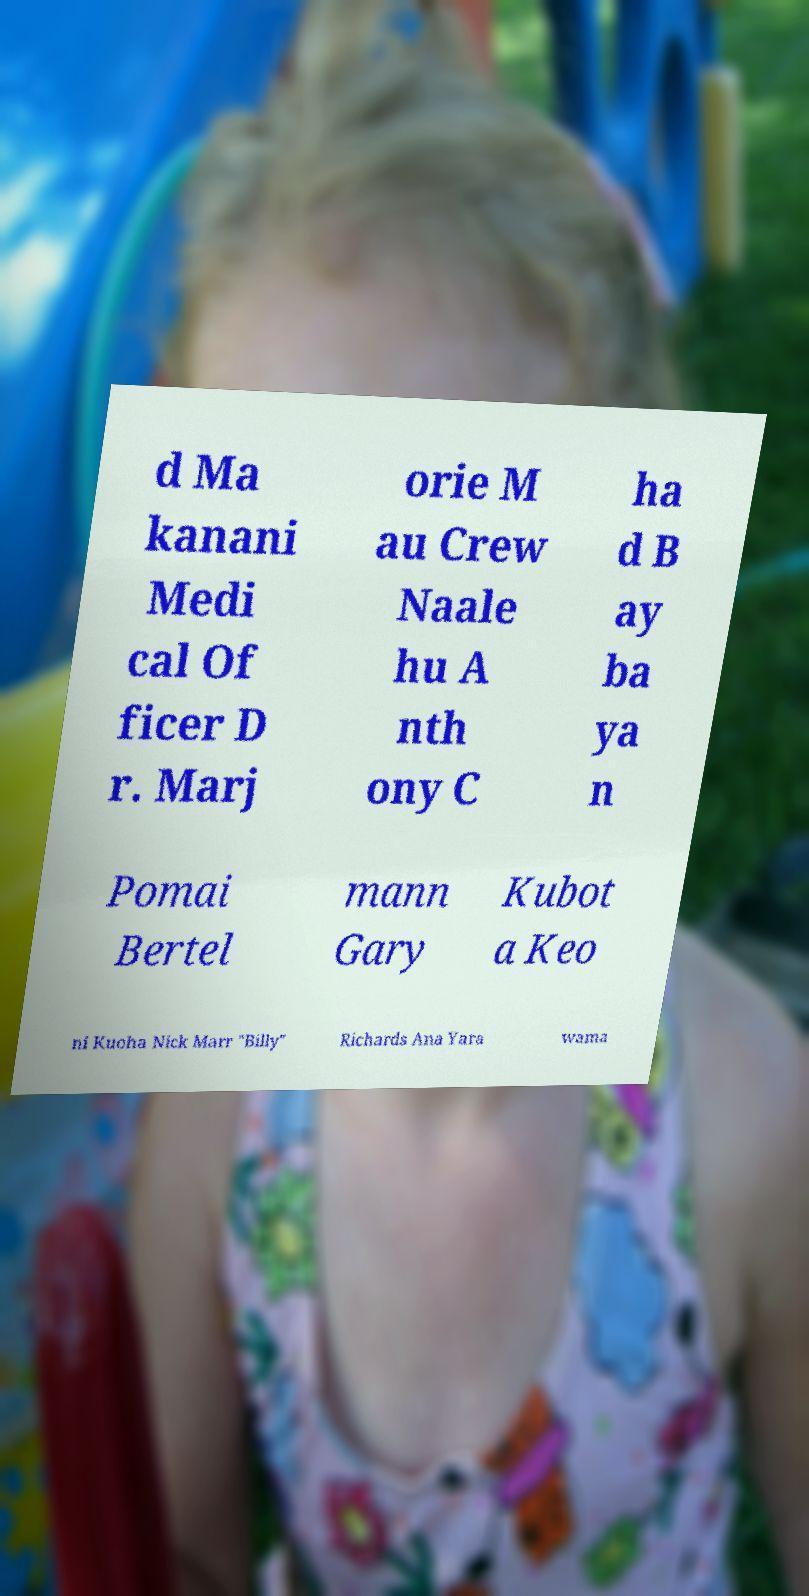What messages or text are displayed in this image? I need them in a readable, typed format. d Ma kanani Medi cal Of ficer D r. Marj orie M au Crew Naale hu A nth ony C ha d B ay ba ya n Pomai Bertel mann Gary Kubot a Keo ni Kuoha Nick Marr "Billy" Richards Ana Yara wama 